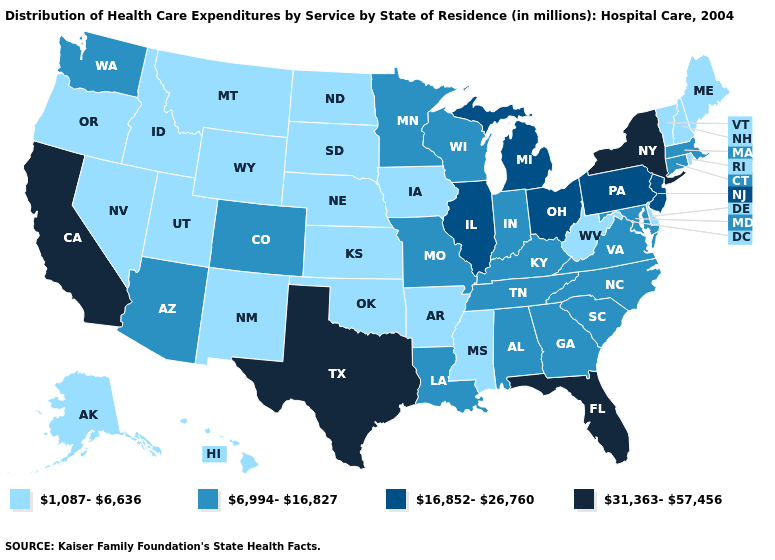Name the states that have a value in the range 16,852-26,760?
Write a very short answer. Illinois, Michigan, New Jersey, Ohio, Pennsylvania. Name the states that have a value in the range 1,087-6,636?
Keep it brief. Alaska, Arkansas, Delaware, Hawaii, Idaho, Iowa, Kansas, Maine, Mississippi, Montana, Nebraska, Nevada, New Hampshire, New Mexico, North Dakota, Oklahoma, Oregon, Rhode Island, South Dakota, Utah, Vermont, West Virginia, Wyoming. What is the value of New York?
Concise answer only. 31,363-57,456. What is the value of Wyoming?
Short answer required. 1,087-6,636. Does Nevada have the lowest value in the West?
Quick response, please. Yes. Name the states that have a value in the range 31,363-57,456?
Answer briefly. California, Florida, New York, Texas. Name the states that have a value in the range 1,087-6,636?
Write a very short answer. Alaska, Arkansas, Delaware, Hawaii, Idaho, Iowa, Kansas, Maine, Mississippi, Montana, Nebraska, Nevada, New Hampshire, New Mexico, North Dakota, Oklahoma, Oregon, Rhode Island, South Dakota, Utah, Vermont, West Virginia, Wyoming. What is the highest value in the Northeast ?
Concise answer only. 31,363-57,456. What is the lowest value in states that border Utah?
Keep it brief. 1,087-6,636. Name the states that have a value in the range 16,852-26,760?
Concise answer only. Illinois, Michigan, New Jersey, Ohio, Pennsylvania. Name the states that have a value in the range 31,363-57,456?
Quick response, please. California, Florida, New York, Texas. What is the lowest value in the Northeast?
Keep it brief. 1,087-6,636. Does Tennessee have the lowest value in the USA?
Answer briefly. No. Name the states that have a value in the range 31,363-57,456?
Write a very short answer. California, Florida, New York, Texas. 